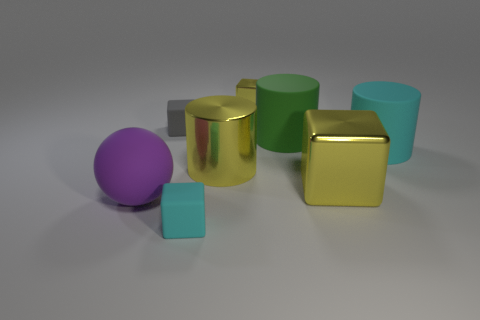What textures are observable on the objects in the image? The objects exhibit two main textures: a matte surface seen on the green cylinder, two cubes, another cylinder, and a sphere, and a reflective, metallic finish on the golden cylinder and the golden cube. 